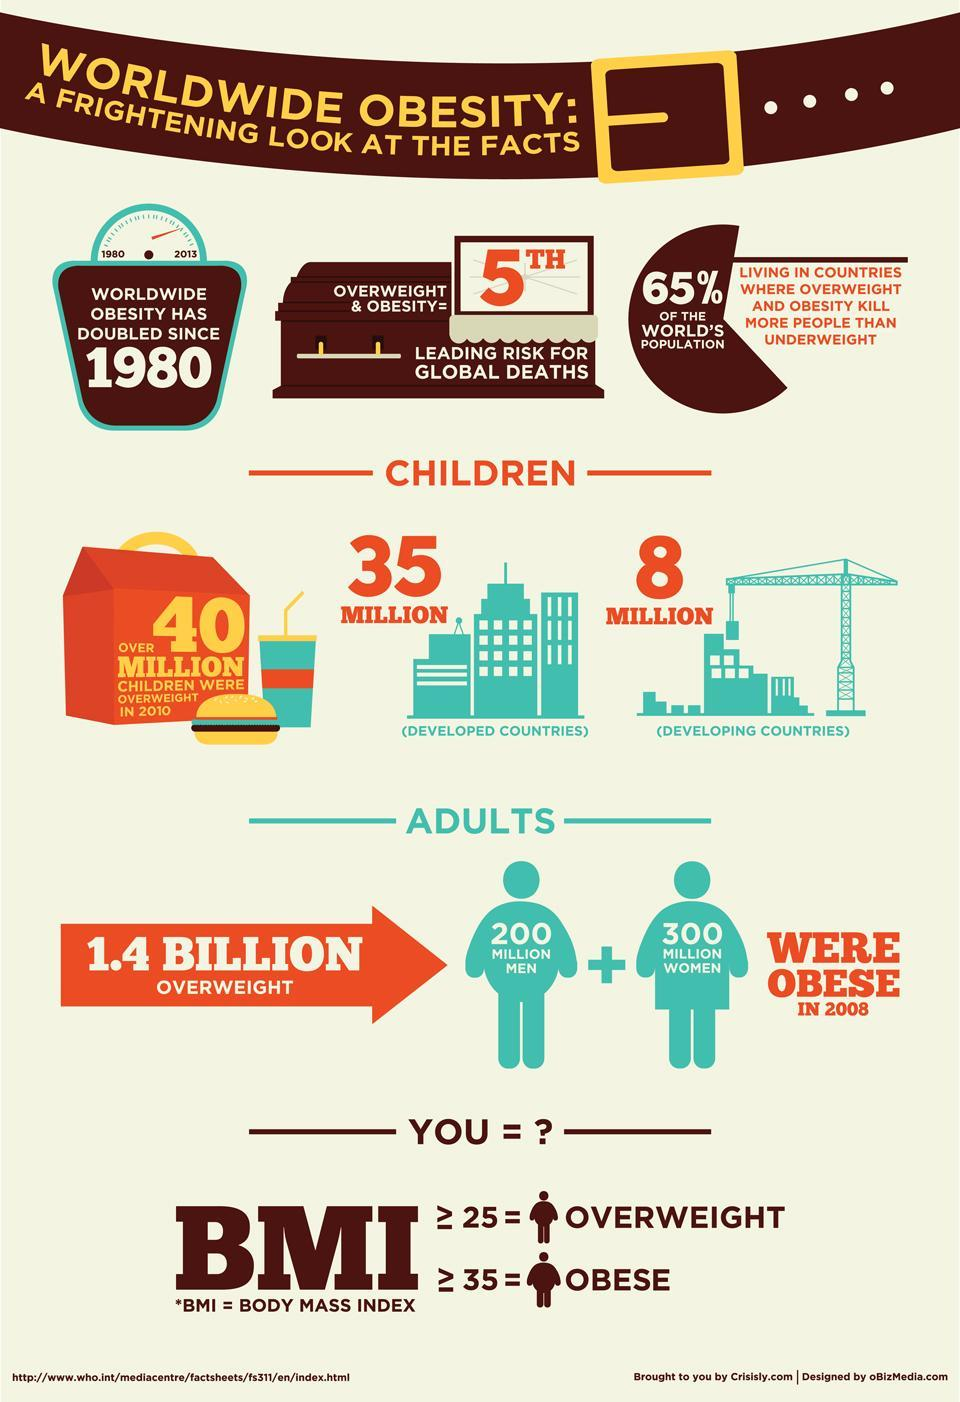How many children in both developed and developing countries were overweight in 2010?
Answer the question with a short phrase. 43 MILLION Which gender was more obese in 2008? WOMEN Who is not overweight- those with BMI <25 OR BMI> 25? BMI<25 